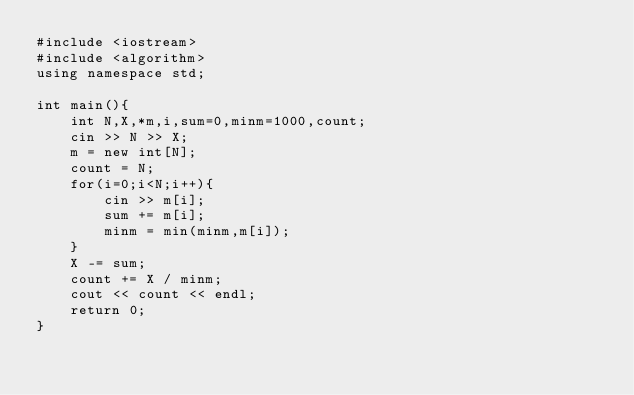<code> <loc_0><loc_0><loc_500><loc_500><_C++_>#include <iostream>
#include <algorithm>
using namespace std;

int main(){
    int N,X,*m,i,sum=0,minm=1000,count;
    cin >> N >> X;
    m = new int[N];
    count = N;
    for(i=0;i<N;i++){
        cin >> m[i];
        sum += m[i];
        minm = min(minm,m[i]);
    }
    X -= sum;
    count += X / minm;
    cout << count << endl;
    return 0;
}</code> 